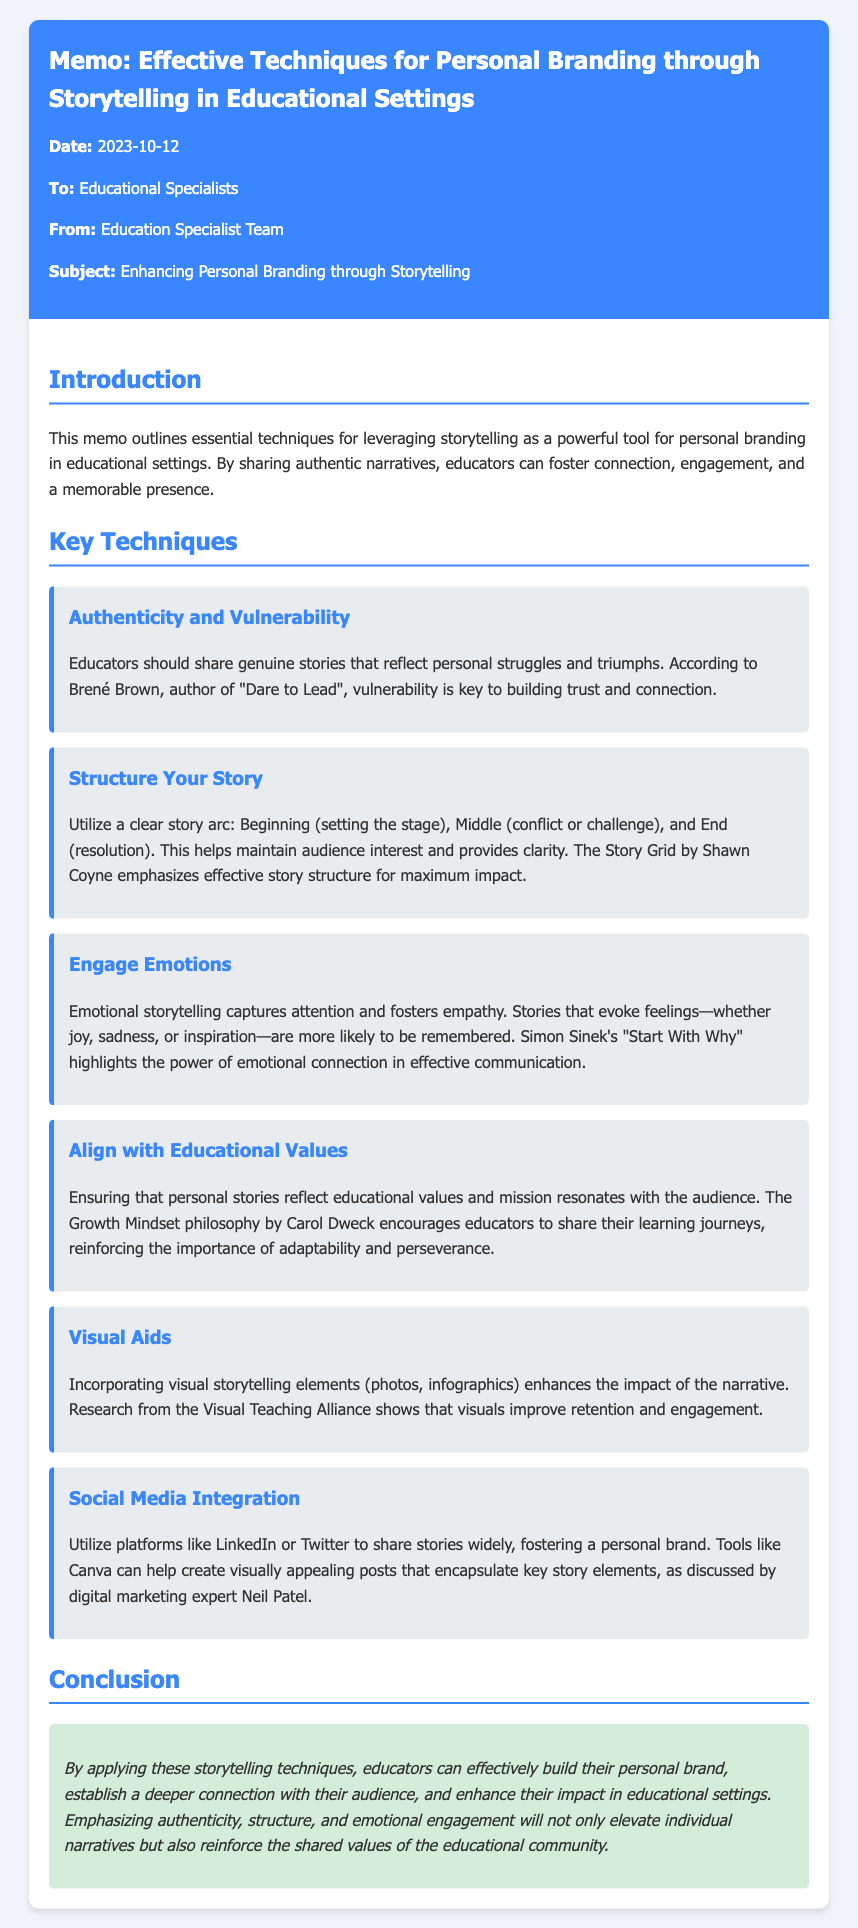What is the date of the memo? The date of the memo is stated in the header section of the document.
Answer: 2023-10-12 Who is the author of the memo? The author of the memo is indicated in the header section.
Answer: Education Specialist Team What technique emphasizes emotional storytelling? The technique that emphasizes emotional storytelling is mentioned in the key techniques section of the document.
Answer: Engage Emotions Which author is referenced for the importance of vulnerability? The author referenced for the importance of vulnerability is mentioned in the section about authenticity.
Answer: Brené Brown What visual element is suggested to enhance storytelling impact? The memo suggests incorporating visual elements as part of the storytelling techniques.
Answer: Visual Aids What does the Growth Mindset philosophy encourage educators to share? The Growth Mindset philosophy encourages sharing personal learning journeys, as discussed in the document.
Answer: Learning journeys How many key techniques are outlined in the memo? The number of key techniques can be counted in the section discussing them.
Answer: Six What is the main purpose of this memo? The main purpose of the memo is stated in the introduction.
Answer: Enhancing Personal Branding through Storytelling Which social media platforms are mentioned as useful for sharing stories? The specific social media platforms recommended for sharing stories are listed in the social media integration technique.
Answer: LinkedIn or Twitter 